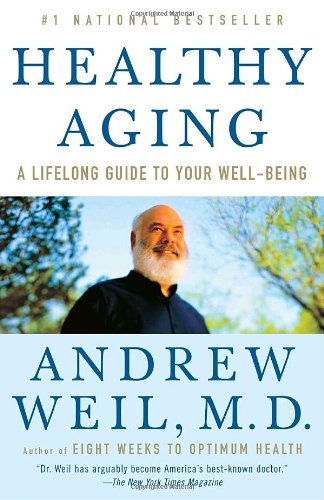What might the significance of the cover design and colors be? The cover design features serene blue tones and an image of the author, suggesting themes of tranquility and trustworthiness. The colors could represent calmness and stability, aligning with the book's focus on sustaining health and well-being as one ages. 